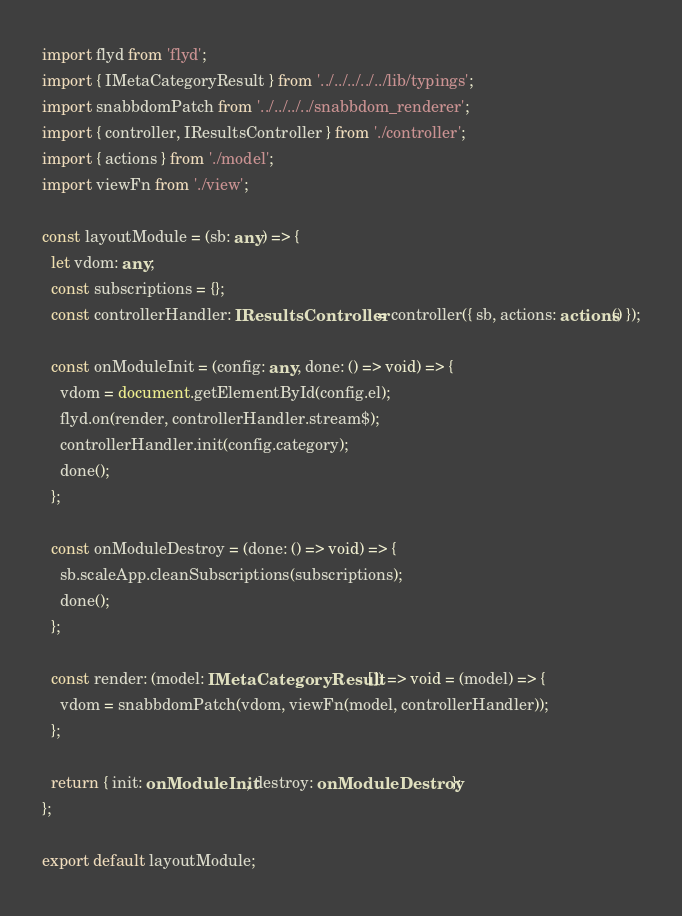Convert code to text. <code><loc_0><loc_0><loc_500><loc_500><_TypeScript_>import flyd from 'flyd';
import { IMetaCategoryResult } from '../../../../../lib/typings';
import snabbdomPatch from '../../../../snabbdom_renderer';
import { controller, IResultsController } from './controller';
import { actions } from './model';
import viewFn from './view';

const layoutModule = (sb: any) => {
  let vdom: any;
  const subscriptions = {};
  const controllerHandler: IResultsController = controller({ sb, actions: actions() });

  const onModuleInit = (config: any, done: () => void) => {
    vdom = document.getElementById(config.el);
    flyd.on(render, controllerHandler.stream$);
    controllerHandler.init(config.category);
    done();
  };

  const onModuleDestroy = (done: () => void) => {
    sb.scaleApp.cleanSubscriptions(subscriptions);
    done();
  };

  const render: (model: IMetaCategoryResult[]) => void = (model) => {
    vdom = snabbdomPatch(vdom, viewFn(model, controllerHandler));
  };

  return { init: onModuleInit, destroy: onModuleDestroy };
};

export default layoutModule;
</code> 